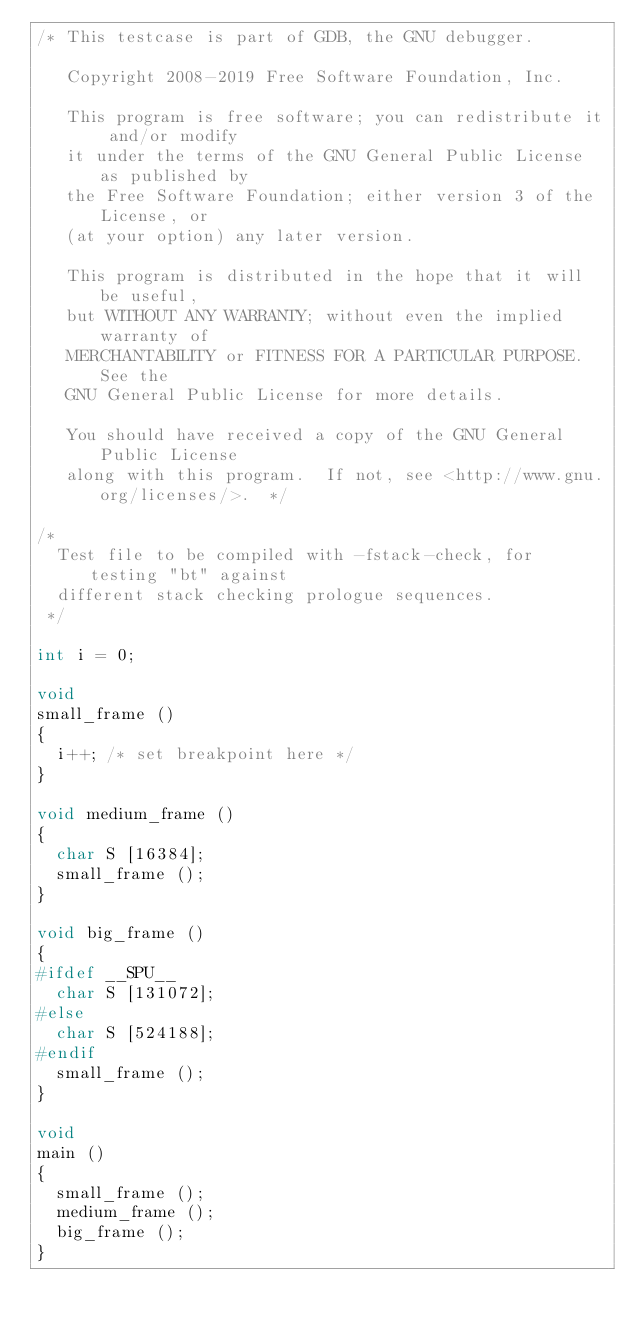<code> <loc_0><loc_0><loc_500><loc_500><_C_>/* This testcase is part of GDB, the GNU debugger.

   Copyright 2008-2019 Free Software Foundation, Inc.

   This program is free software; you can redistribute it and/or modify
   it under the terms of the GNU General Public License as published by
   the Free Software Foundation; either version 3 of the License, or
   (at your option) any later version.

   This program is distributed in the hope that it will be useful,
   but WITHOUT ANY WARRANTY; without even the implied warranty of
   MERCHANTABILITY or FITNESS FOR A PARTICULAR PURPOSE.  See the
   GNU General Public License for more details.

   You should have received a copy of the GNU General Public License
   along with this program.  If not, see <http://www.gnu.org/licenses/>.  */

/*
  Test file to be compiled with -fstack-check, for testing "bt" against
  different stack checking prologue sequences.
 */

int i = 0;

void
small_frame ()
{
  i++; /* set breakpoint here */
}

void medium_frame ()
{
  char S [16384];
  small_frame ();
}

void big_frame ()
{
#ifdef __SPU__
  char S [131072];
#else
  char S [524188];
#endif
  small_frame ();
}

void
main ()
{
  small_frame ();
  medium_frame ();
  big_frame ();
}
</code> 